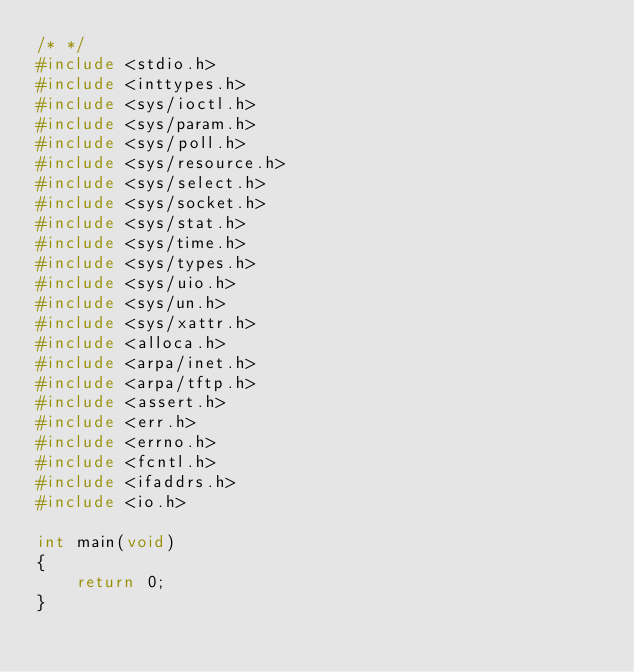<code> <loc_0><loc_0><loc_500><loc_500><_C_>/* */
#include <stdio.h>
#include <inttypes.h>
#include <sys/ioctl.h>
#include <sys/param.h>
#include <sys/poll.h>
#include <sys/resource.h>
#include <sys/select.h>
#include <sys/socket.h>
#include <sys/stat.h>
#include <sys/time.h>
#include <sys/types.h>
#include <sys/uio.h>
#include <sys/un.h>
#include <sys/xattr.h>
#include <alloca.h>
#include <arpa/inet.h>
#include <arpa/tftp.h>
#include <assert.h>
#include <err.h>
#include <errno.h>
#include <fcntl.h>
#include <ifaddrs.h>
#include <io.h>

int main(void)
{
    return 0;
}
</code> 